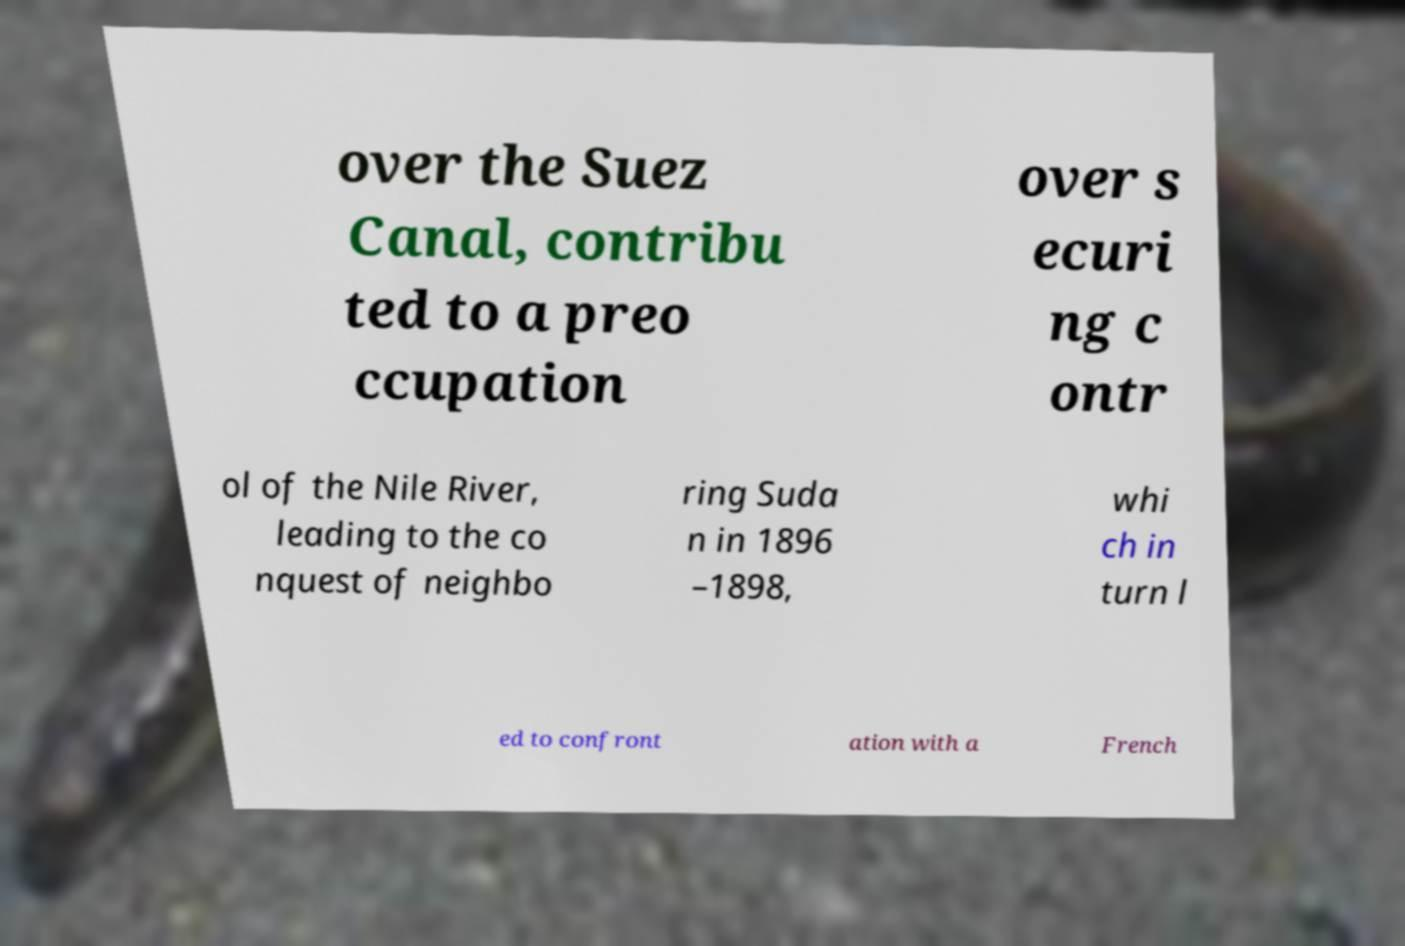Please identify and transcribe the text found in this image. over the Suez Canal, contribu ted to a preo ccupation over s ecuri ng c ontr ol of the Nile River, leading to the co nquest of neighbo ring Suda n in 1896 –1898, whi ch in turn l ed to confront ation with a French 